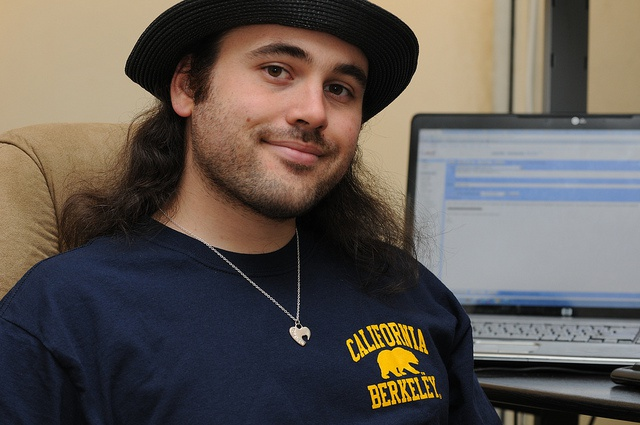Describe the objects in this image and their specific colors. I can see people in tan, black, gray, and maroon tones, laptop in tan, darkgray, black, and gray tones, chair in tan, gray, and brown tones, and couch in tan, gray, and brown tones in this image. 